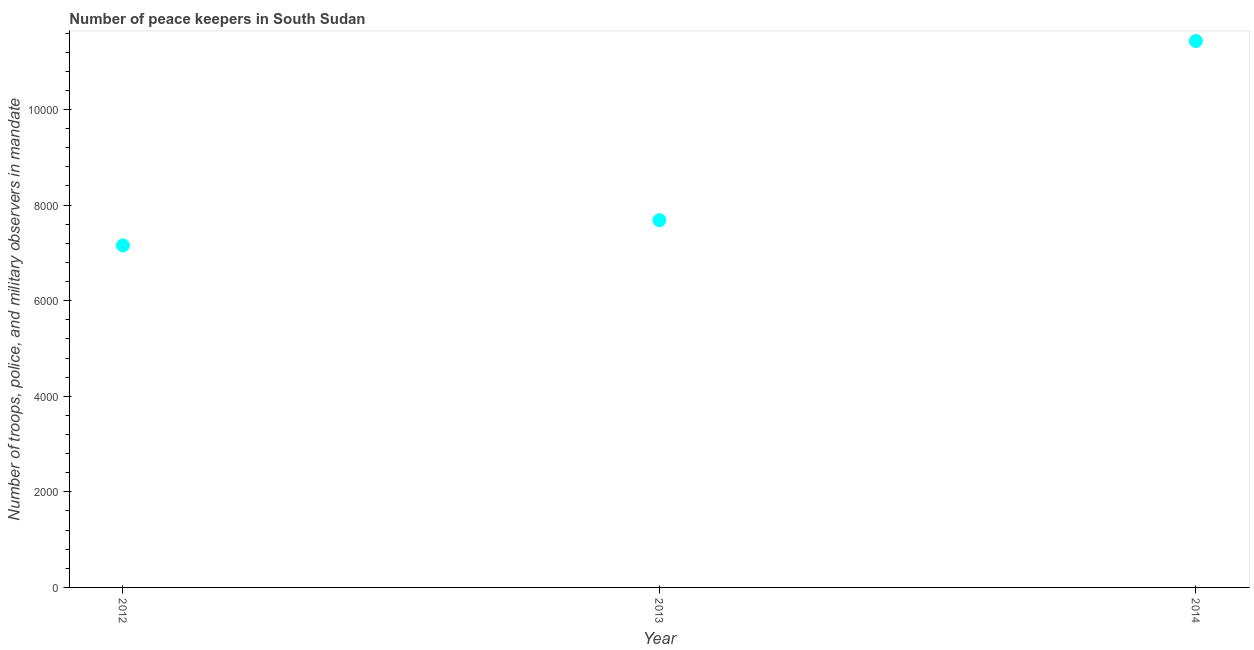What is the number of peace keepers in 2012?
Your answer should be very brief. 7157. Across all years, what is the maximum number of peace keepers?
Ensure brevity in your answer.  1.14e+04. Across all years, what is the minimum number of peace keepers?
Ensure brevity in your answer.  7157. In which year was the number of peace keepers maximum?
Provide a short and direct response. 2014. In which year was the number of peace keepers minimum?
Your response must be concise. 2012. What is the sum of the number of peace keepers?
Offer a terse response. 2.63e+04. What is the difference between the number of peace keepers in 2012 and 2014?
Offer a terse response. -4276. What is the average number of peace keepers per year?
Provide a short and direct response. 8758. What is the median number of peace keepers?
Offer a terse response. 7684. In how many years, is the number of peace keepers greater than 2400 ?
Make the answer very short. 3. What is the ratio of the number of peace keepers in 2012 to that in 2014?
Keep it short and to the point. 0.63. Is the difference between the number of peace keepers in 2013 and 2014 greater than the difference between any two years?
Offer a very short reply. No. What is the difference between the highest and the second highest number of peace keepers?
Offer a very short reply. 3749. Is the sum of the number of peace keepers in 2012 and 2013 greater than the maximum number of peace keepers across all years?
Offer a very short reply. Yes. What is the difference between the highest and the lowest number of peace keepers?
Provide a short and direct response. 4276. Does the number of peace keepers monotonically increase over the years?
Offer a very short reply. Yes. What is the difference between two consecutive major ticks on the Y-axis?
Offer a very short reply. 2000. Does the graph contain grids?
Provide a short and direct response. No. What is the title of the graph?
Keep it short and to the point. Number of peace keepers in South Sudan. What is the label or title of the X-axis?
Your answer should be compact. Year. What is the label or title of the Y-axis?
Your answer should be very brief. Number of troops, police, and military observers in mandate. What is the Number of troops, police, and military observers in mandate in 2012?
Give a very brief answer. 7157. What is the Number of troops, police, and military observers in mandate in 2013?
Offer a terse response. 7684. What is the Number of troops, police, and military observers in mandate in 2014?
Your answer should be very brief. 1.14e+04. What is the difference between the Number of troops, police, and military observers in mandate in 2012 and 2013?
Make the answer very short. -527. What is the difference between the Number of troops, police, and military observers in mandate in 2012 and 2014?
Your response must be concise. -4276. What is the difference between the Number of troops, police, and military observers in mandate in 2013 and 2014?
Offer a very short reply. -3749. What is the ratio of the Number of troops, police, and military observers in mandate in 2012 to that in 2013?
Keep it short and to the point. 0.93. What is the ratio of the Number of troops, police, and military observers in mandate in 2012 to that in 2014?
Offer a very short reply. 0.63. What is the ratio of the Number of troops, police, and military observers in mandate in 2013 to that in 2014?
Give a very brief answer. 0.67. 